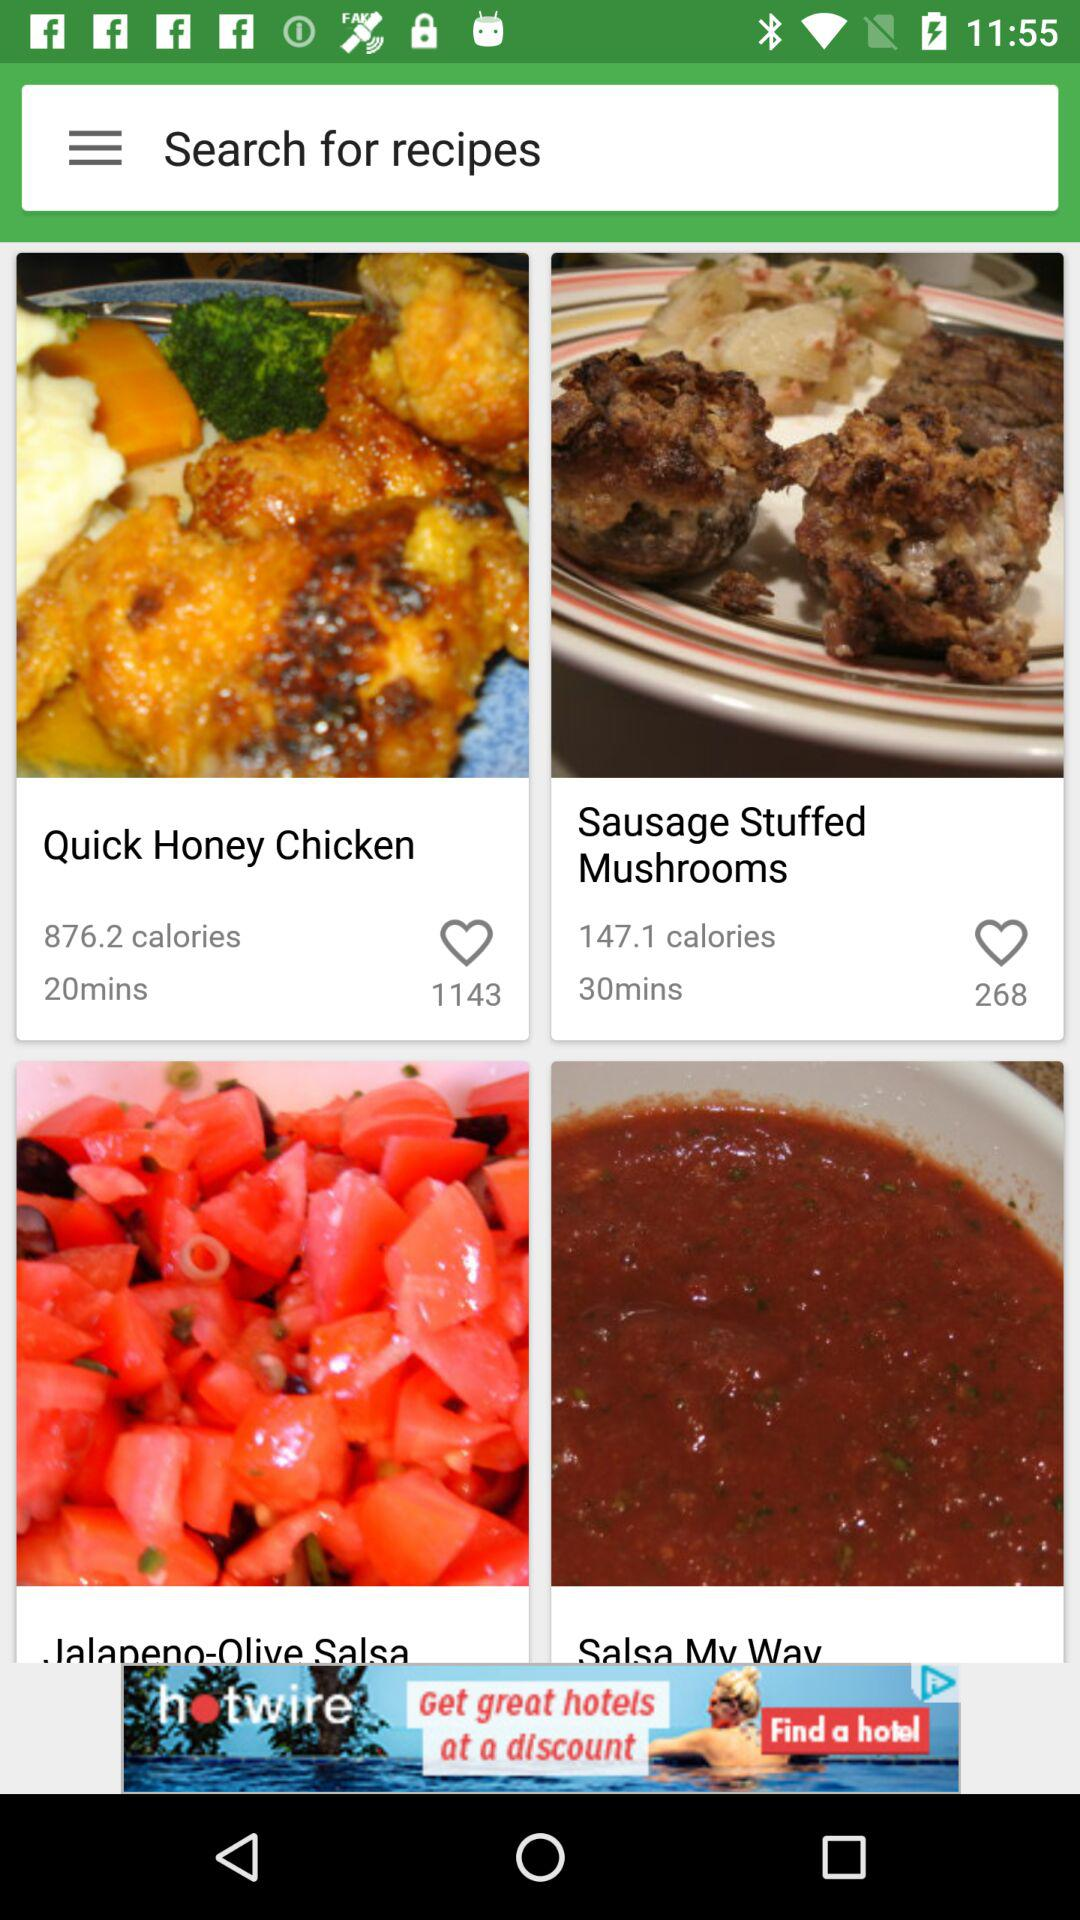How many calories are in "Sausage Stuffed Mushrooms"? There are 147.1 calories in "Sausage Stuffed Mushrooms". 